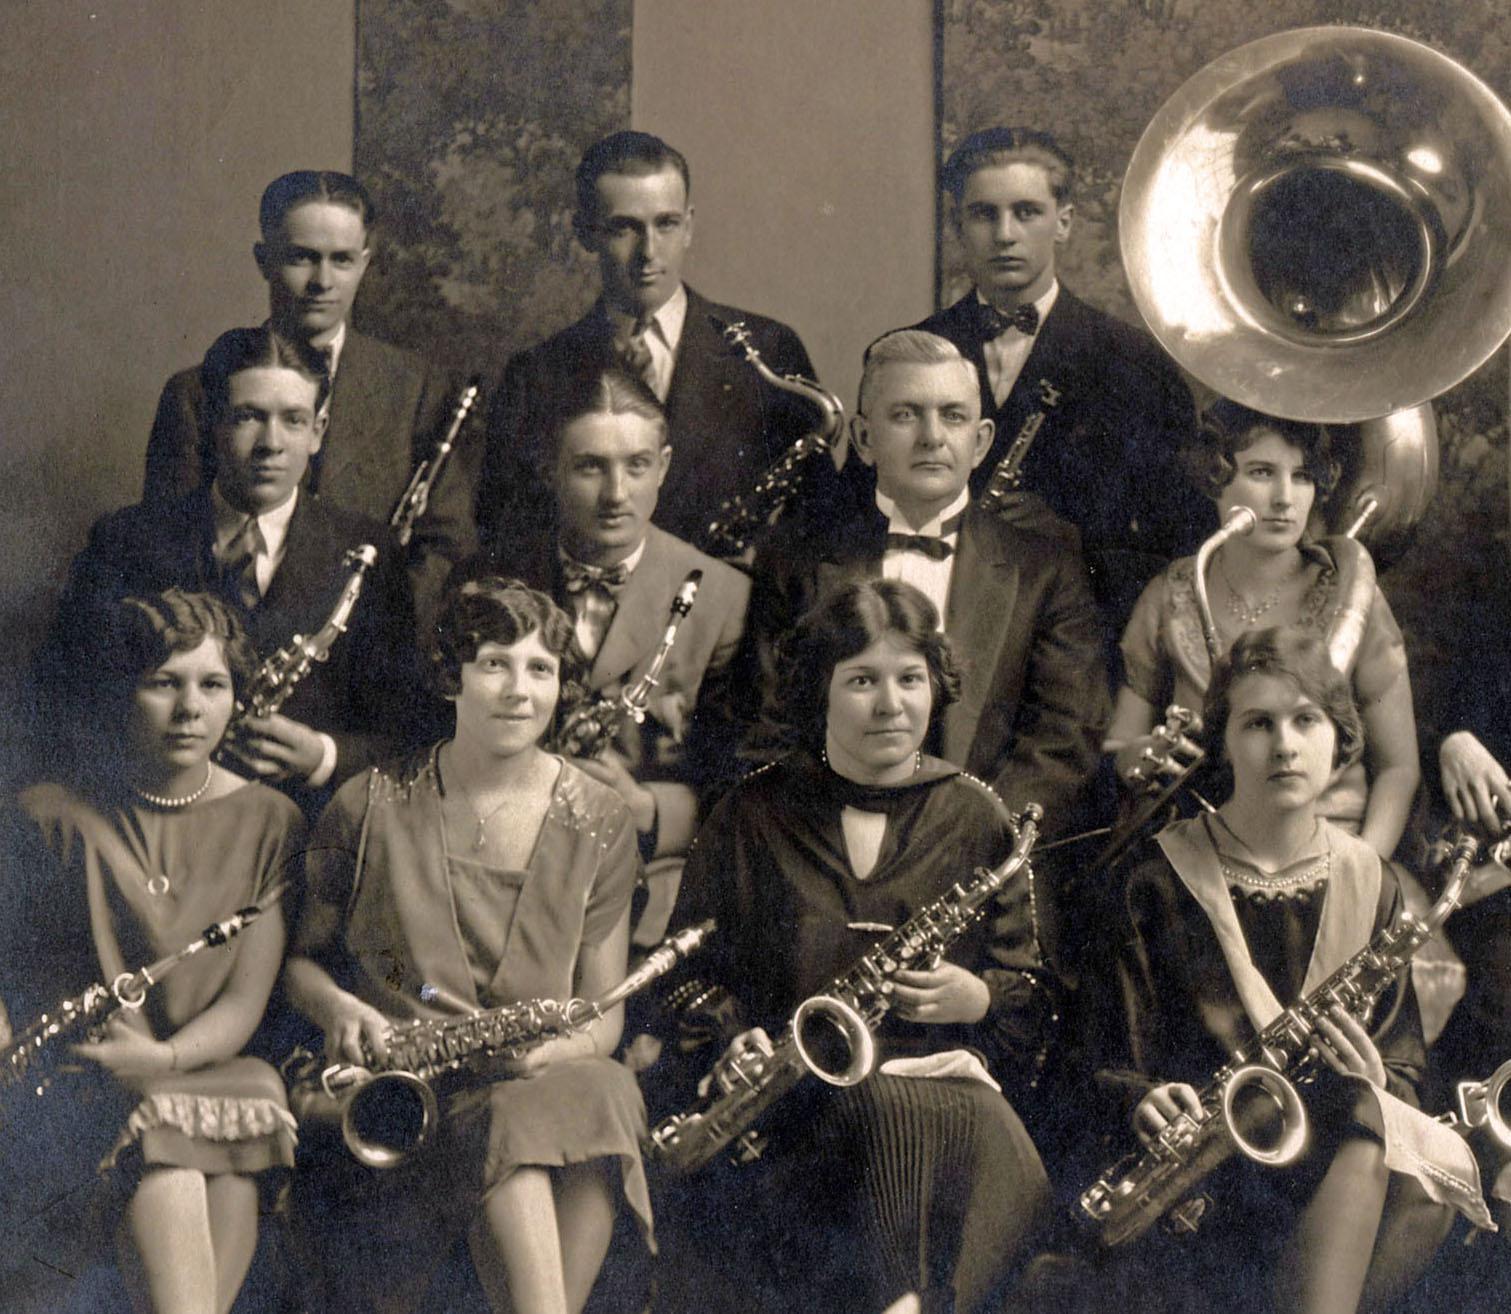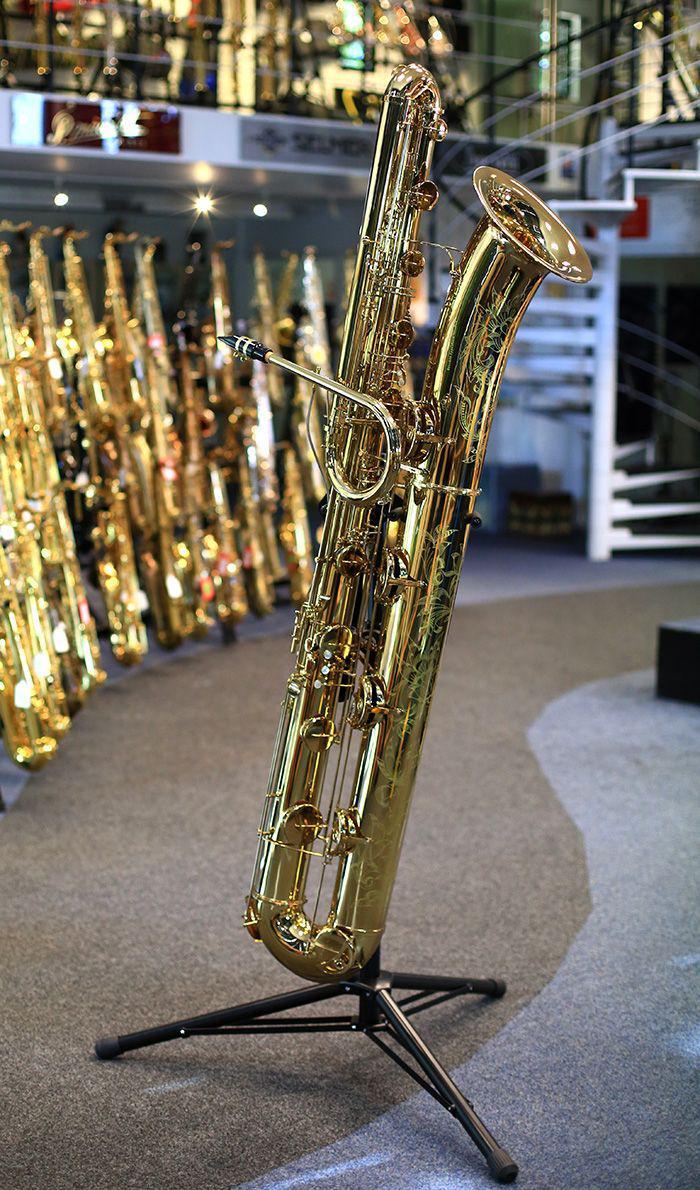The first image is the image on the left, the second image is the image on the right. Analyze the images presented: Is the assertion "At least four musicians hold saxophones in one image." valid? Answer yes or no. Yes. The first image is the image on the left, the second image is the image on the right. Considering the images on both sides, is "A saxophone is sitting on a black stand in the image on the right." valid? Answer yes or no. Yes. 